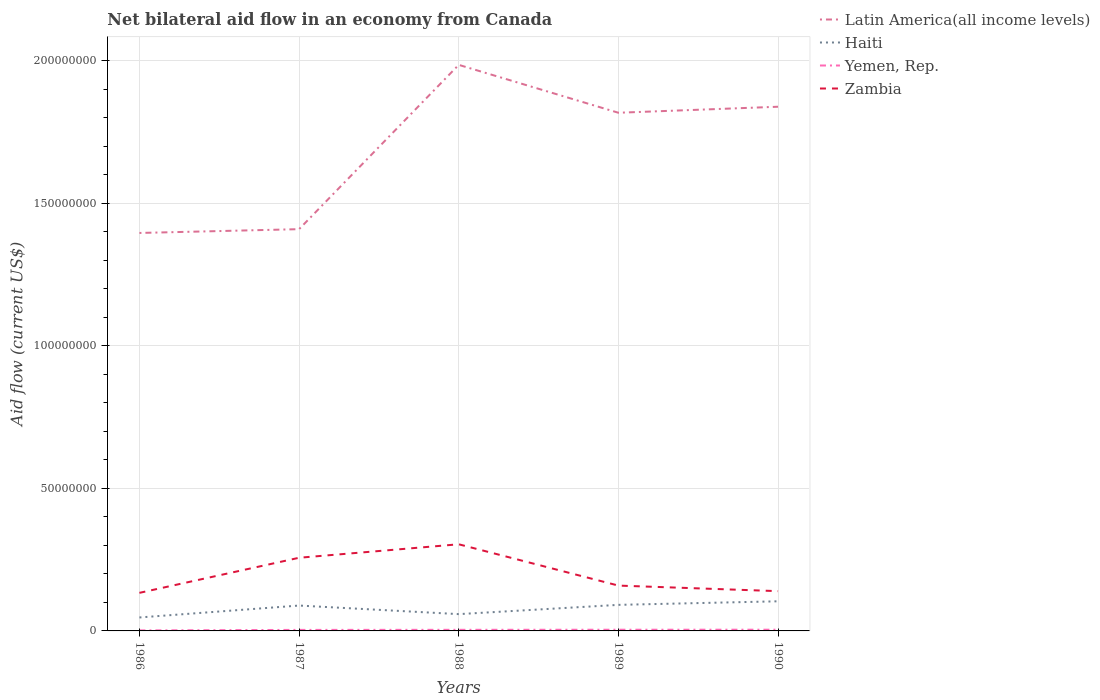How many different coloured lines are there?
Offer a very short reply. 4. Does the line corresponding to Yemen, Rep. intersect with the line corresponding to Haiti?
Provide a short and direct response. No. Across all years, what is the maximum net bilateral aid flow in Zambia?
Make the answer very short. 1.34e+07. What is the total net bilateral aid flow in Haiti in the graph?
Your answer should be compact. 3.01e+06. How many lines are there?
Your response must be concise. 4. Where does the legend appear in the graph?
Make the answer very short. Top right. How many legend labels are there?
Offer a very short reply. 4. What is the title of the graph?
Your response must be concise. Net bilateral aid flow in an economy from Canada. What is the label or title of the Y-axis?
Your answer should be very brief. Aid flow (current US$). What is the Aid flow (current US$) of Latin America(all income levels) in 1986?
Your answer should be very brief. 1.40e+08. What is the Aid flow (current US$) of Haiti in 1986?
Provide a succinct answer. 4.72e+06. What is the Aid flow (current US$) of Yemen, Rep. in 1986?
Make the answer very short. 1.80e+05. What is the Aid flow (current US$) in Zambia in 1986?
Ensure brevity in your answer.  1.34e+07. What is the Aid flow (current US$) of Latin America(all income levels) in 1987?
Give a very brief answer. 1.41e+08. What is the Aid flow (current US$) of Haiti in 1987?
Keep it short and to the point. 8.90e+06. What is the Aid flow (current US$) of Zambia in 1987?
Make the answer very short. 2.57e+07. What is the Aid flow (current US$) in Latin America(all income levels) in 1988?
Provide a short and direct response. 1.99e+08. What is the Aid flow (current US$) of Haiti in 1988?
Offer a terse response. 5.89e+06. What is the Aid flow (current US$) of Yemen, Rep. in 1988?
Give a very brief answer. 3.90e+05. What is the Aid flow (current US$) of Zambia in 1988?
Make the answer very short. 3.04e+07. What is the Aid flow (current US$) of Latin America(all income levels) in 1989?
Your response must be concise. 1.82e+08. What is the Aid flow (current US$) of Haiti in 1989?
Offer a terse response. 9.14e+06. What is the Aid flow (current US$) of Yemen, Rep. in 1989?
Your response must be concise. 4.20e+05. What is the Aid flow (current US$) of Zambia in 1989?
Keep it short and to the point. 1.59e+07. What is the Aid flow (current US$) in Latin America(all income levels) in 1990?
Your response must be concise. 1.84e+08. What is the Aid flow (current US$) of Haiti in 1990?
Provide a short and direct response. 1.04e+07. What is the Aid flow (current US$) of Zambia in 1990?
Your response must be concise. 1.40e+07. Across all years, what is the maximum Aid flow (current US$) of Latin America(all income levels)?
Ensure brevity in your answer.  1.99e+08. Across all years, what is the maximum Aid flow (current US$) in Haiti?
Provide a short and direct response. 1.04e+07. Across all years, what is the maximum Aid flow (current US$) of Yemen, Rep.?
Give a very brief answer. 4.30e+05. Across all years, what is the maximum Aid flow (current US$) of Zambia?
Ensure brevity in your answer.  3.04e+07. Across all years, what is the minimum Aid flow (current US$) in Latin America(all income levels)?
Offer a terse response. 1.40e+08. Across all years, what is the minimum Aid flow (current US$) in Haiti?
Provide a short and direct response. 4.72e+06. Across all years, what is the minimum Aid flow (current US$) of Yemen, Rep.?
Ensure brevity in your answer.  1.80e+05. Across all years, what is the minimum Aid flow (current US$) of Zambia?
Your answer should be compact. 1.34e+07. What is the total Aid flow (current US$) in Latin America(all income levels) in the graph?
Your answer should be very brief. 8.45e+08. What is the total Aid flow (current US$) in Haiti in the graph?
Provide a short and direct response. 3.90e+07. What is the total Aid flow (current US$) of Yemen, Rep. in the graph?
Offer a very short reply. 1.78e+06. What is the total Aid flow (current US$) in Zambia in the graph?
Your response must be concise. 9.92e+07. What is the difference between the Aid flow (current US$) of Latin America(all income levels) in 1986 and that in 1987?
Make the answer very short. -1.33e+06. What is the difference between the Aid flow (current US$) of Haiti in 1986 and that in 1987?
Your answer should be compact. -4.18e+06. What is the difference between the Aid flow (current US$) in Zambia in 1986 and that in 1987?
Offer a very short reply. -1.23e+07. What is the difference between the Aid flow (current US$) of Latin America(all income levels) in 1986 and that in 1988?
Your response must be concise. -5.90e+07. What is the difference between the Aid flow (current US$) in Haiti in 1986 and that in 1988?
Keep it short and to the point. -1.17e+06. What is the difference between the Aid flow (current US$) in Yemen, Rep. in 1986 and that in 1988?
Your response must be concise. -2.10e+05. What is the difference between the Aid flow (current US$) in Zambia in 1986 and that in 1988?
Your answer should be compact. -1.70e+07. What is the difference between the Aid flow (current US$) of Latin America(all income levels) in 1986 and that in 1989?
Provide a short and direct response. -4.22e+07. What is the difference between the Aid flow (current US$) of Haiti in 1986 and that in 1989?
Offer a terse response. -4.42e+06. What is the difference between the Aid flow (current US$) in Yemen, Rep. in 1986 and that in 1989?
Make the answer very short. -2.40e+05. What is the difference between the Aid flow (current US$) in Zambia in 1986 and that in 1989?
Provide a succinct answer. -2.55e+06. What is the difference between the Aid flow (current US$) of Latin America(all income levels) in 1986 and that in 1990?
Ensure brevity in your answer.  -4.43e+07. What is the difference between the Aid flow (current US$) of Haiti in 1986 and that in 1990?
Your answer should be very brief. -5.67e+06. What is the difference between the Aid flow (current US$) in Zambia in 1986 and that in 1990?
Keep it short and to the point. -6.00e+05. What is the difference between the Aid flow (current US$) of Latin America(all income levels) in 1987 and that in 1988?
Keep it short and to the point. -5.76e+07. What is the difference between the Aid flow (current US$) of Haiti in 1987 and that in 1988?
Offer a terse response. 3.01e+06. What is the difference between the Aid flow (current US$) in Yemen, Rep. in 1987 and that in 1988?
Keep it short and to the point. -3.00e+04. What is the difference between the Aid flow (current US$) in Zambia in 1987 and that in 1988?
Your answer should be compact. -4.73e+06. What is the difference between the Aid flow (current US$) in Latin America(all income levels) in 1987 and that in 1989?
Your answer should be very brief. -4.08e+07. What is the difference between the Aid flow (current US$) of Haiti in 1987 and that in 1989?
Provide a short and direct response. -2.40e+05. What is the difference between the Aid flow (current US$) in Zambia in 1987 and that in 1989?
Offer a terse response. 9.76e+06. What is the difference between the Aid flow (current US$) of Latin America(all income levels) in 1987 and that in 1990?
Keep it short and to the point. -4.29e+07. What is the difference between the Aid flow (current US$) in Haiti in 1987 and that in 1990?
Keep it short and to the point. -1.49e+06. What is the difference between the Aid flow (current US$) of Zambia in 1987 and that in 1990?
Make the answer very short. 1.17e+07. What is the difference between the Aid flow (current US$) in Latin America(all income levels) in 1988 and that in 1989?
Your answer should be compact. 1.68e+07. What is the difference between the Aid flow (current US$) in Haiti in 1988 and that in 1989?
Keep it short and to the point. -3.25e+06. What is the difference between the Aid flow (current US$) in Zambia in 1988 and that in 1989?
Offer a terse response. 1.45e+07. What is the difference between the Aid flow (current US$) in Latin America(all income levels) in 1988 and that in 1990?
Give a very brief answer. 1.47e+07. What is the difference between the Aid flow (current US$) in Haiti in 1988 and that in 1990?
Your answer should be compact. -4.50e+06. What is the difference between the Aid flow (current US$) in Zambia in 1988 and that in 1990?
Ensure brevity in your answer.  1.64e+07. What is the difference between the Aid flow (current US$) in Latin America(all income levels) in 1989 and that in 1990?
Your answer should be very brief. -2.11e+06. What is the difference between the Aid flow (current US$) in Haiti in 1989 and that in 1990?
Make the answer very short. -1.25e+06. What is the difference between the Aid flow (current US$) of Yemen, Rep. in 1989 and that in 1990?
Provide a succinct answer. -10000. What is the difference between the Aid flow (current US$) of Zambia in 1989 and that in 1990?
Offer a terse response. 1.95e+06. What is the difference between the Aid flow (current US$) of Latin America(all income levels) in 1986 and the Aid flow (current US$) of Haiti in 1987?
Ensure brevity in your answer.  1.31e+08. What is the difference between the Aid flow (current US$) of Latin America(all income levels) in 1986 and the Aid flow (current US$) of Yemen, Rep. in 1987?
Give a very brief answer. 1.39e+08. What is the difference between the Aid flow (current US$) in Latin America(all income levels) in 1986 and the Aid flow (current US$) in Zambia in 1987?
Your answer should be very brief. 1.14e+08. What is the difference between the Aid flow (current US$) of Haiti in 1986 and the Aid flow (current US$) of Yemen, Rep. in 1987?
Provide a succinct answer. 4.36e+06. What is the difference between the Aid flow (current US$) of Haiti in 1986 and the Aid flow (current US$) of Zambia in 1987?
Your response must be concise. -2.09e+07. What is the difference between the Aid flow (current US$) in Yemen, Rep. in 1986 and the Aid flow (current US$) in Zambia in 1987?
Provide a short and direct response. -2.55e+07. What is the difference between the Aid flow (current US$) in Latin America(all income levels) in 1986 and the Aid flow (current US$) in Haiti in 1988?
Offer a terse response. 1.34e+08. What is the difference between the Aid flow (current US$) of Latin America(all income levels) in 1986 and the Aid flow (current US$) of Yemen, Rep. in 1988?
Your answer should be compact. 1.39e+08. What is the difference between the Aid flow (current US$) of Latin America(all income levels) in 1986 and the Aid flow (current US$) of Zambia in 1988?
Your answer should be compact. 1.09e+08. What is the difference between the Aid flow (current US$) of Haiti in 1986 and the Aid flow (current US$) of Yemen, Rep. in 1988?
Your answer should be compact. 4.33e+06. What is the difference between the Aid flow (current US$) of Haiti in 1986 and the Aid flow (current US$) of Zambia in 1988?
Offer a terse response. -2.57e+07. What is the difference between the Aid flow (current US$) in Yemen, Rep. in 1986 and the Aid flow (current US$) in Zambia in 1988?
Provide a short and direct response. -3.02e+07. What is the difference between the Aid flow (current US$) in Latin America(all income levels) in 1986 and the Aid flow (current US$) in Haiti in 1989?
Offer a very short reply. 1.30e+08. What is the difference between the Aid flow (current US$) in Latin America(all income levels) in 1986 and the Aid flow (current US$) in Yemen, Rep. in 1989?
Ensure brevity in your answer.  1.39e+08. What is the difference between the Aid flow (current US$) of Latin America(all income levels) in 1986 and the Aid flow (current US$) of Zambia in 1989?
Your answer should be very brief. 1.24e+08. What is the difference between the Aid flow (current US$) of Haiti in 1986 and the Aid flow (current US$) of Yemen, Rep. in 1989?
Offer a very short reply. 4.30e+06. What is the difference between the Aid flow (current US$) in Haiti in 1986 and the Aid flow (current US$) in Zambia in 1989?
Give a very brief answer. -1.12e+07. What is the difference between the Aid flow (current US$) of Yemen, Rep. in 1986 and the Aid flow (current US$) of Zambia in 1989?
Offer a terse response. -1.57e+07. What is the difference between the Aid flow (current US$) of Latin America(all income levels) in 1986 and the Aid flow (current US$) of Haiti in 1990?
Ensure brevity in your answer.  1.29e+08. What is the difference between the Aid flow (current US$) in Latin America(all income levels) in 1986 and the Aid flow (current US$) in Yemen, Rep. in 1990?
Give a very brief answer. 1.39e+08. What is the difference between the Aid flow (current US$) of Latin America(all income levels) in 1986 and the Aid flow (current US$) of Zambia in 1990?
Keep it short and to the point. 1.26e+08. What is the difference between the Aid flow (current US$) in Haiti in 1986 and the Aid flow (current US$) in Yemen, Rep. in 1990?
Your answer should be compact. 4.29e+06. What is the difference between the Aid flow (current US$) of Haiti in 1986 and the Aid flow (current US$) of Zambia in 1990?
Ensure brevity in your answer.  -9.23e+06. What is the difference between the Aid flow (current US$) of Yemen, Rep. in 1986 and the Aid flow (current US$) of Zambia in 1990?
Offer a very short reply. -1.38e+07. What is the difference between the Aid flow (current US$) in Latin America(all income levels) in 1987 and the Aid flow (current US$) in Haiti in 1988?
Give a very brief answer. 1.35e+08. What is the difference between the Aid flow (current US$) in Latin America(all income levels) in 1987 and the Aid flow (current US$) in Yemen, Rep. in 1988?
Your answer should be compact. 1.41e+08. What is the difference between the Aid flow (current US$) in Latin America(all income levels) in 1987 and the Aid flow (current US$) in Zambia in 1988?
Your answer should be very brief. 1.11e+08. What is the difference between the Aid flow (current US$) in Haiti in 1987 and the Aid flow (current US$) in Yemen, Rep. in 1988?
Provide a short and direct response. 8.51e+06. What is the difference between the Aid flow (current US$) of Haiti in 1987 and the Aid flow (current US$) of Zambia in 1988?
Make the answer very short. -2.15e+07. What is the difference between the Aid flow (current US$) in Yemen, Rep. in 1987 and the Aid flow (current US$) in Zambia in 1988?
Provide a short and direct response. -3.00e+07. What is the difference between the Aid flow (current US$) in Latin America(all income levels) in 1987 and the Aid flow (current US$) in Haiti in 1989?
Your response must be concise. 1.32e+08. What is the difference between the Aid flow (current US$) in Latin America(all income levels) in 1987 and the Aid flow (current US$) in Yemen, Rep. in 1989?
Make the answer very short. 1.40e+08. What is the difference between the Aid flow (current US$) of Latin America(all income levels) in 1987 and the Aid flow (current US$) of Zambia in 1989?
Offer a very short reply. 1.25e+08. What is the difference between the Aid flow (current US$) of Haiti in 1987 and the Aid flow (current US$) of Yemen, Rep. in 1989?
Your answer should be compact. 8.48e+06. What is the difference between the Aid flow (current US$) of Haiti in 1987 and the Aid flow (current US$) of Zambia in 1989?
Provide a short and direct response. -7.00e+06. What is the difference between the Aid flow (current US$) in Yemen, Rep. in 1987 and the Aid flow (current US$) in Zambia in 1989?
Offer a very short reply. -1.55e+07. What is the difference between the Aid flow (current US$) of Latin America(all income levels) in 1987 and the Aid flow (current US$) of Haiti in 1990?
Offer a very short reply. 1.31e+08. What is the difference between the Aid flow (current US$) in Latin America(all income levels) in 1987 and the Aid flow (current US$) in Yemen, Rep. in 1990?
Provide a short and direct response. 1.40e+08. What is the difference between the Aid flow (current US$) of Latin America(all income levels) in 1987 and the Aid flow (current US$) of Zambia in 1990?
Offer a terse response. 1.27e+08. What is the difference between the Aid flow (current US$) in Haiti in 1987 and the Aid flow (current US$) in Yemen, Rep. in 1990?
Keep it short and to the point. 8.47e+06. What is the difference between the Aid flow (current US$) in Haiti in 1987 and the Aid flow (current US$) in Zambia in 1990?
Your answer should be very brief. -5.05e+06. What is the difference between the Aid flow (current US$) in Yemen, Rep. in 1987 and the Aid flow (current US$) in Zambia in 1990?
Your answer should be compact. -1.36e+07. What is the difference between the Aid flow (current US$) of Latin America(all income levels) in 1988 and the Aid flow (current US$) of Haiti in 1989?
Your answer should be compact. 1.89e+08. What is the difference between the Aid flow (current US$) in Latin America(all income levels) in 1988 and the Aid flow (current US$) in Yemen, Rep. in 1989?
Your answer should be very brief. 1.98e+08. What is the difference between the Aid flow (current US$) in Latin America(all income levels) in 1988 and the Aid flow (current US$) in Zambia in 1989?
Ensure brevity in your answer.  1.83e+08. What is the difference between the Aid flow (current US$) of Haiti in 1988 and the Aid flow (current US$) of Yemen, Rep. in 1989?
Make the answer very short. 5.47e+06. What is the difference between the Aid flow (current US$) of Haiti in 1988 and the Aid flow (current US$) of Zambia in 1989?
Make the answer very short. -1.00e+07. What is the difference between the Aid flow (current US$) in Yemen, Rep. in 1988 and the Aid flow (current US$) in Zambia in 1989?
Give a very brief answer. -1.55e+07. What is the difference between the Aid flow (current US$) of Latin America(all income levels) in 1988 and the Aid flow (current US$) of Haiti in 1990?
Provide a short and direct response. 1.88e+08. What is the difference between the Aid flow (current US$) of Latin America(all income levels) in 1988 and the Aid flow (current US$) of Yemen, Rep. in 1990?
Give a very brief answer. 1.98e+08. What is the difference between the Aid flow (current US$) of Latin America(all income levels) in 1988 and the Aid flow (current US$) of Zambia in 1990?
Offer a terse response. 1.85e+08. What is the difference between the Aid flow (current US$) of Haiti in 1988 and the Aid flow (current US$) of Yemen, Rep. in 1990?
Provide a succinct answer. 5.46e+06. What is the difference between the Aid flow (current US$) in Haiti in 1988 and the Aid flow (current US$) in Zambia in 1990?
Keep it short and to the point. -8.06e+06. What is the difference between the Aid flow (current US$) of Yemen, Rep. in 1988 and the Aid flow (current US$) of Zambia in 1990?
Offer a terse response. -1.36e+07. What is the difference between the Aid flow (current US$) of Latin America(all income levels) in 1989 and the Aid flow (current US$) of Haiti in 1990?
Your answer should be very brief. 1.71e+08. What is the difference between the Aid flow (current US$) of Latin America(all income levels) in 1989 and the Aid flow (current US$) of Yemen, Rep. in 1990?
Your response must be concise. 1.81e+08. What is the difference between the Aid flow (current US$) of Latin America(all income levels) in 1989 and the Aid flow (current US$) of Zambia in 1990?
Keep it short and to the point. 1.68e+08. What is the difference between the Aid flow (current US$) in Haiti in 1989 and the Aid flow (current US$) in Yemen, Rep. in 1990?
Keep it short and to the point. 8.71e+06. What is the difference between the Aid flow (current US$) of Haiti in 1989 and the Aid flow (current US$) of Zambia in 1990?
Provide a short and direct response. -4.81e+06. What is the difference between the Aid flow (current US$) of Yemen, Rep. in 1989 and the Aid flow (current US$) of Zambia in 1990?
Offer a very short reply. -1.35e+07. What is the average Aid flow (current US$) in Latin America(all income levels) per year?
Make the answer very short. 1.69e+08. What is the average Aid flow (current US$) of Haiti per year?
Make the answer very short. 7.81e+06. What is the average Aid flow (current US$) in Yemen, Rep. per year?
Give a very brief answer. 3.56e+05. What is the average Aid flow (current US$) in Zambia per year?
Provide a succinct answer. 1.98e+07. In the year 1986, what is the difference between the Aid flow (current US$) of Latin America(all income levels) and Aid flow (current US$) of Haiti?
Ensure brevity in your answer.  1.35e+08. In the year 1986, what is the difference between the Aid flow (current US$) in Latin America(all income levels) and Aid flow (current US$) in Yemen, Rep.?
Offer a very short reply. 1.39e+08. In the year 1986, what is the difference between the Aid flow (current US$) of Latin America(all income levels) and Aid flow (current US$) of Zambia?
Keep it short and to the point. 1.26e+08. In the year 1986, what is the difference between the Aid flow (current US$) in Haiti and Aid flow (current US$) in Yemen, Rep.?
Your response must be concise. 4.54e+06. In the year 1986, what is the difference between the Aid flow (current US$) in Haiti and Aid flow (current US$) in Zambia?
Make the answer very short. -8.63e+06. In the year 1986, what is the difference between the Aid flow (current US$) in Yemen, Rep. and Aid flow (current US$) in Zambia?
Your answer should be compact. -1.32e+07. In the year 1987, what is the difference between the Aid flow (current US$) of Latin America(all income levels) and Aid flow (current US$) of Haiti?
Your answer should be very brief. 1.32e+08. In the year 1987, what is the difference between the Aid flow (current US$) in Latin America(all income levels) and Aid flow (current US$) in Yemen, Rep.?
Give a very brief answer. 1.41e+08. In the year 1987, what is the difference between the Aid flow (current US$) in Latin America(all income levels) and Aid flow (current US$) in Zambia?
Keep it short and to the point. 1.15e+08. In the year 1987, what is the difference between the Aid flow (current US$) in Haiti and Aid flow (current US$) in Yemen, Rep.?
Keep it short and to the point. 8.54e+06. In the year 1987, what is the difference between the Aid flow (current US$) in Haiti and Aid flow (current US$) in Zambia?
Your response must be concise. -1.68e+07. In the year 1987, what is the difference between the Aid flow (current US$) of Yemen, Rep. and Aid flow (current US$) of Zambia?
Keep it short and to the point. -2.53e+07. In the year 1988, what is the difference between the Aid flow (current US$) of Latin America(all income levels) and Aid flow (current US$) of Haiti?
Your answer should be compact. 1.93e+08. In the year 1988, what is the difference between the Aid flow (current US$) of Latin America(all income levels) and Aid flow (current US$) of Yemen, Rep.?
Ensure brevity in your answer.  1.98e+08. In the year 1988, what is the difference between the Aid flow (current US$) in Latin America(all income levels) and Aid flow (current US$) in Zambia?
Ensure brevity in your answer.  1.68e+08. In the year 1988, what is the difference between the Aid flow (current US$) of Haiti and Aid flow (current US$) of Yemen, Rep.?
Your answer should be very brief. 5.50e+06. In the year 1988, what is the difference between the Aid flow (current US$) of Haiti and Aid flow (current US$) of Zambia?
Keep it short and to the point. -2.45e+07. In the year 1988, what is the difference between the Aid flow (current US$) in Yemen, Rep. and Aid flow (current US$) in Zambia?
Make the answer very short. -3.00e+07. In the year 1989, what is the difference between the Aid flow (current US$) of Latin America(all income levels) and Aid flow (current US$) of Haiti?
Ensure brevity in your answer.  1.73e+08. In the year 1989, what is the difference between the Aid flow (current US$) in Latin America(all income levels) and Aid flow (current US$) in Yemen, Rep.?
Your answer should be very brief. 1.81e+08. In the year 1989, what is the difference between the Aid flow (current US$) in Latin America(all income levels) and Aid flow (current US$) in Zambia?
Your answer should be compact. 1.66e+08. In the year 1989, what is the difference between the Aid flow (current US$) of Haiti and Aid flow (current US$) of Yemen, Rep.?
Provide a short and direct response. 8.72e+06. In the year 1989, what is the difference between the Aid flow (current US$) in Haiti and Aid flow (current US$) in Zambia?
Ensure brevity in your answer.  -6.76e+06. In the year 1989, what is the difference between the Aid flow (current US$) in Yemen, Rep. and Aid flow (current US$) in Zambia?
Keep it short and to the point. -1.55e+07. In the year 1990, what is the difference between the Aid flow (current US$) of Latin America(all income levels) and Aid flow (current US$) of Haiti?
Offer a very short reply. 1.73e+08. In the year 1990, what is the difference between the Aid flow (current US$) in Latin America(all income levels) and Aid flow (current US$) in Yemen, Rep.?
Provide a short and direct response. 1.83e+08. In the year 1990, what is the difference between the Aid flow (current US$) in Latin America(all income levels) and Aid flow (current US$) in Zambia?
Provide a short and direct response. 1.70e+08. In the year 1990, what is the difference between the Aid flow (current US$) in Haiti and Aid flow (current US$) in Yemen, Rep.?
Your answer should be very brief. 9.96e+06. In the year 1990, what is the difference between the Aid flow (current US$) of Haiti and Aid flow (current US$) of Zambia?
Your response must be concise. -3.56e+06. In the year 1990, what is the difference between the Aid flow (current US$) in Yemen, Rep. and Aid flow (current US$) in Zambia?
Give a very brief answer. -1.35e+07. What is the ratio of the Aid flow (current US$) of Latin America(all income levels) in 1986 to that in 1987?
Offer a very short reply. 0.99. What is the ratio of the Aid flow (current US$) in Haiti in 1986 to that in 1987?
Ensure brevity in your answer.  0.53. What is the ratio of the Aid flow (current US$) in Zambia in 1986 to that in 1987?
Provide a short and direct response. 0.52. What is the ratio of the Aid flow (current US$) of Latin America(all income levels) in 1986 to that in 1988?
Give a very brief answer. 0.7. What is the ratio of the Aid flow (current US$) of Haiti in 1986 to that in 1988?
Your answer should be compact. 0.8. What is the ratio of the Aid flow (current US$) of Yemen, Rep. in 1986 to that in 1988?
Offer a very short reply. 0.46. What is the ratio of the Aid flow (current US$) in Zambia in 1986 to that in 1988?
Offer a terse response. 0.44. What is the ratio of the Aid flow (current US$) of Latin America(all income levels) in 1986 to that in 1989?
Make the answer very short. 0.77. What is the ratio of the Aid flow (current US$) in Haiti in 1986 to that in 1989?
Offer a very short reply. 0.52. What is the ratio of the Aid flow (current US$) in Yemen, Rep. in 1986 to that in 1989?
Your answer should be compact. 0.43. What is the ratio of the Aid flow (current US$) of Zambia in 1986 to that in 1989?
Provide a short and direct response. 0.84. What is the ratio of the Aid flow (current US$) in Latin America(all income levels) in 1986 to that in 1990?
Provide a succinct answer. 0.76. What is the ratio of the Aid flow (current US$) of Haiti in 1986 to that in 1990?
Give a very brief answer. 0.45. What is the ratio of the Aid flow (current US$) in Yemen, Rep. in 1986 to that in 1990?
Your answer should be compact. 0.42. What is the ratio of the Aid flow (current US$) in Zambia in 1986 to that in 1990?
Provide a succinct answer. 0.96. What is the ratio of the Aid flow (current US$) in Latin America(all income levels) in 1987 to that in 1988?
Your answer should be very brief. 0.71. What is the ratio of the Aid flow (current US$) in Haiti in 1987 to that in 1988?
Your response must be concise. 1.51. What is the ratio of the Aid flow (current US$) of Yemen, Rep. in 1987 to that in 1988?
Keep it short and to the point. 0.92. What is the ratio of the Aid flow (current US$) of Zambia in 1987 to that in 1988?
Provide a succinct answer. 0.84. What is the ratio of the Aid flow (current US$) of Latin America(all income levels) in 1987 to that in 1989?
Make the answer very short. 0.78. What is the ratio of the Aid flow (current US$) in Haiti in 1987 to that in 1989?
Your response must be concise. 0.97. What is the ratio of the Aid flow (current US$) in Yemen, Rep. in 1987 to that in 1989?
Your response must be concise. 0.86. What is the ratio of the Aid flow (current US$) in Zambia in 1987 to that in 1989?
Offer a terse response. 1.61. What is the ratio of the Aid flow (current US$) of Latin America(all income levels) in 1987 to that in 1990?
Provide a succinct answer. 0.77. What is the ratio of the Aid flow (current US$) in Haiti in 1987 to that in 1990?
Offer a very short reply. 0.86. What is the ratio of the Aid flow (current US$) in Yemen, Rep. in 1987 to that in 1990?
Provide a succinct answer. 0.84. What is the ratio of the Aid flow (current US$) in Zambia in 1987 to that in 1990?
Ensure brevity in your answer.  1.84. What is the ratio of the Aid flow (current US$) in Latin America(all income levels) in 1988 to that in 1989?
Keep it short and to the point. 1.09. What is the ratio of the Aid flow (current US$) in Haiti in 1988 to that in 1989?
Offer a terse response. 0.64. What is the ratio of the Aid flow (current US$) in Zambia in 1988 to that in 1989?
Offer a very short reply. 1.91. What is the ratio of the Aid flow (current US$) of Latin America(all income levels) in 1988 to that in 1990?
Your response must be concise. 1.08. What is the ratio of the Aid flow (current US$) in Haiti in 1988 to that in 1990?
Ensure brevity in your answer.  0.57. What is the ratio of the Aid flow (current US$) of Yemen, Rep. in 1988 to that in 1990?
Your response must be concise. 0.91. What is the ratio of the Aid flow (current US$) of Zambia in 1988 to that in 1990?
Your answer should be compact. 2.18. What is the ratio of the Aid flow (current US$) in Haiti in 1989 to that in 1990?
Provide a short and direct response. 0.88. What is the ratio of the Aid flow (current US$) of Yemen, Rep. in 1989 to that in 1990?
Make the answer very short. 0.98. What is the ratio of the Aid flow (current US$) in Zambia in 1989 to that in 1990?
Your answer should be compact. 1.14. What is the difference between the highest and the second highest Aid flow (current US$) of Latin America(all income levels)?
Provide a succinct answer. 1.47e+07. What is the difference between the highest and the second highest Aid flow (current US$) in Haiti?
Ensure brevity in your answer.  1.25e+06. What is the difference between the highest and the second highest Aid flow (current US$) in Zambia?
Your response must be concise. 4.73e+06. What is the difference between the highest and the lowest Aid flow (current US$) in Latin America(all income levels)?
Your answer should be very brief. 5.90e+07. What is the difference between the highest and the lowest Aid flow (current US$) of Haiti?
Provide a short and direct response. 5.67e+06. What is the difference between the highest and the lowest Aid flow (current US$) in Zambia?
Ensure brevity in your answer.  1.70e+07. 